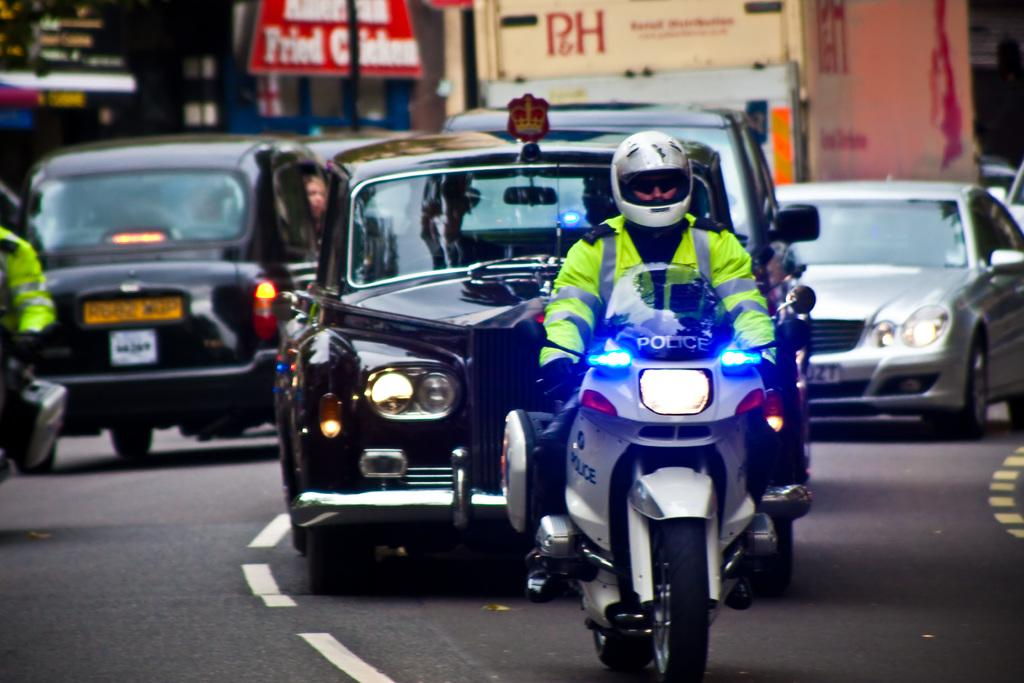What is the police officer doing in the image? The police officer is riding a motorcycle in the image. What can be seen moving behind the motorcycle? A black color car is moving on the road behind the motorcycle. What type of establishments are on the left side of the image? There are stores on the left side of the image. What type of cup is being used by the police officer while riding the motorcycle? There is no cup visible in the image, as the police officer is riding a motorcycle. 